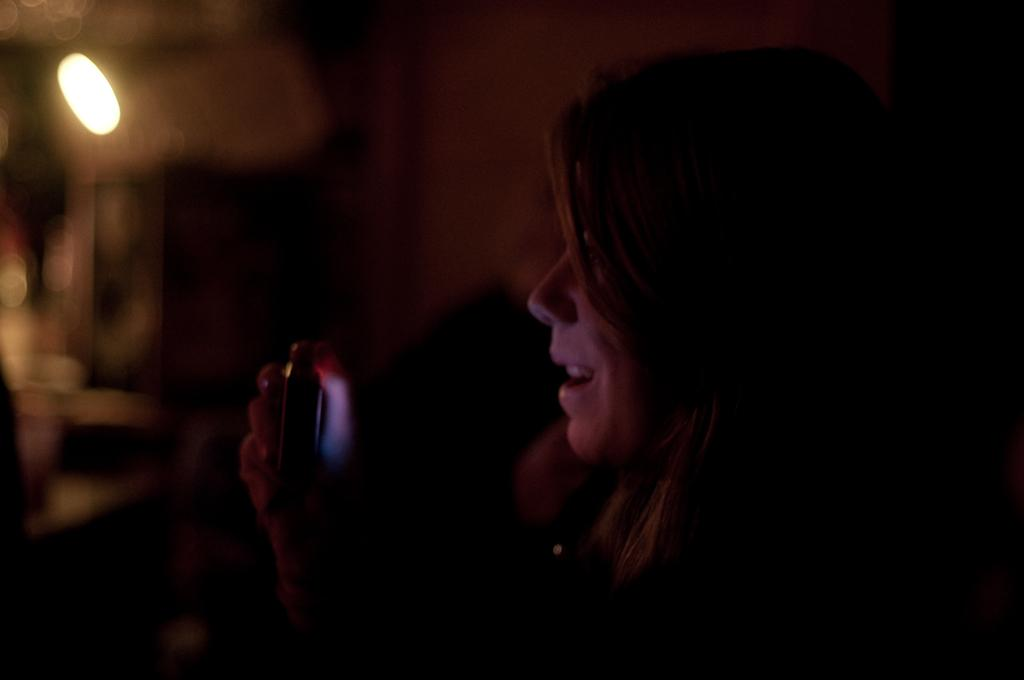Who is the main subject in the image? There is a woman in the image. What can be observed about the background of the image? The background of the image is dark. What type of nerve can be seen in the image? There is no nerve present in the image. What shape is the spade in the image? There is no spade present in the image. 